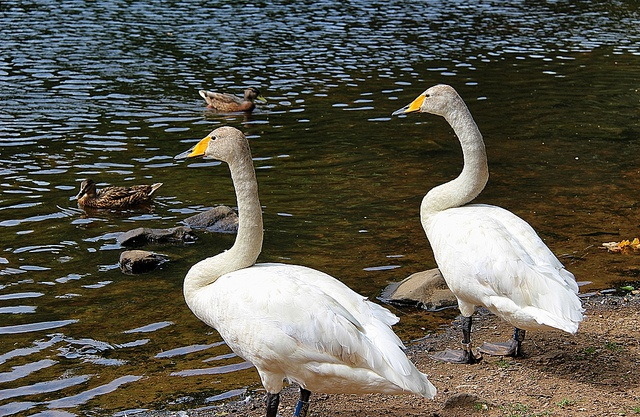Describe the objects in this image and their specific colors. I can see bird in teal, lightgray, darkgray, and gray tones, bird in teal, white, black, darkgray, and gray tones, bird in teal, black, gray, and maroon tones, and bird in teal, black, maroon, and gray tones in this image. 